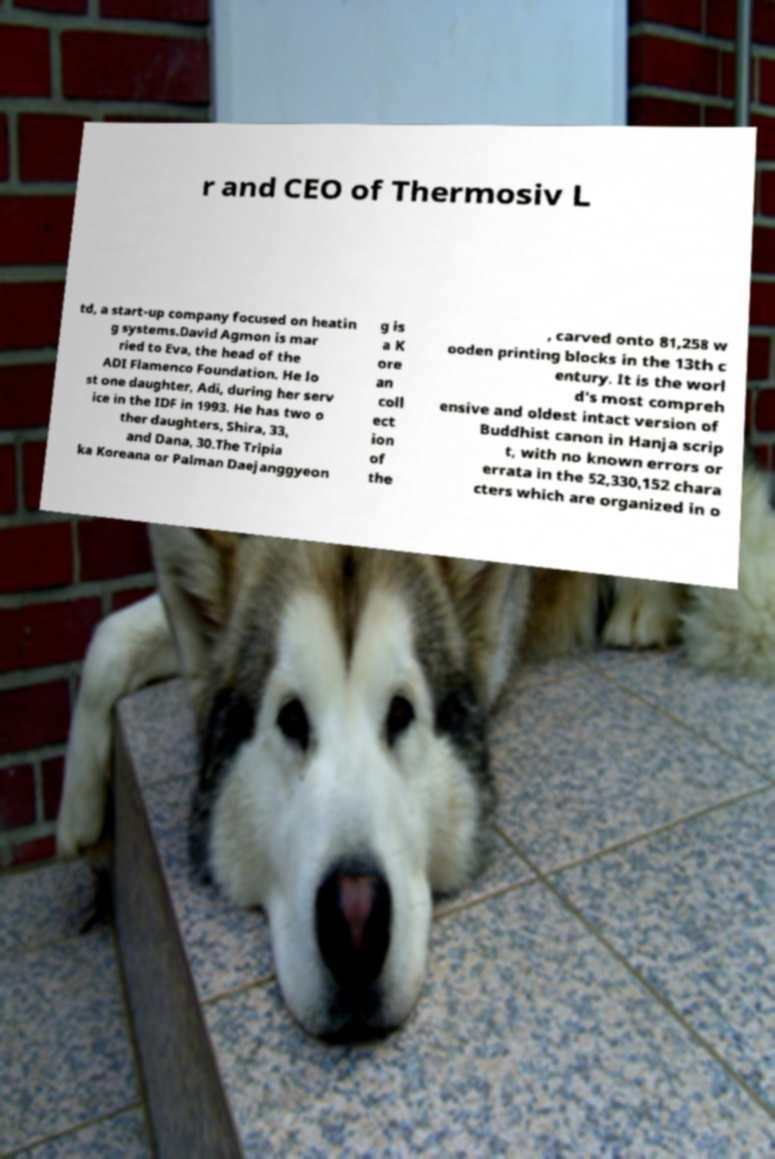For documentation purposes, I need the text within this image transcribed. Could you provide that? r and CEO of Thermosiv L td, a start-up company focused on heatin g systems.David Agmon is mar ried to Eva, the head of the ADI Flamenco Foundation. He lo st one daughter, Adi, during her serv ice in the IDF in 1993. He has two o ther daughters, Shira, 33, and Dana, 30.The Tripia ka Koreana or Palman Daejanggyeon g is a K ore an coll ect ion of the , carved onto 81,258 w ooden printing blocks in the 13th c entury. It is the worl d's most compreh ensive and oldest intact version of Buddhist canon in Hanja scrip t, with no known errors or errata in the 52,330,152 chara cters which are organized in o 